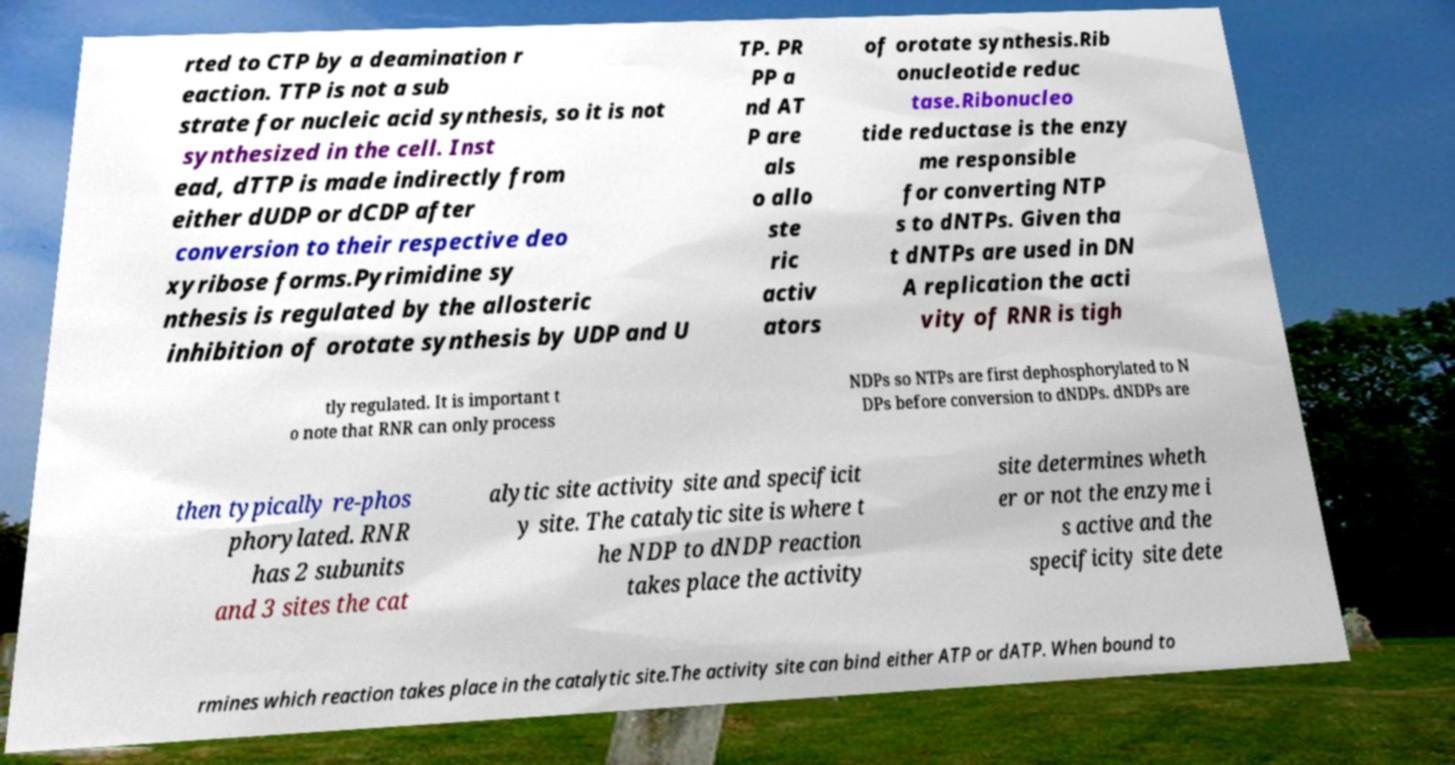Could you assist in decoding the text presented in this image and type it out clearly? rted to CTP by a deamination r eaction. TTP is not a sub strate for nucleic acid synthesis, so it is not synthesized in the cell. Inst ead, dTTP is made indirectly from either dUDP or dCDP after conversion to their respective deo xyribose forms.Pyrimidine sy nthesis is regulated by the allosteric inhibition of orotate synthesis by UDP and U TP. PR PP a nd AT P are als o allo ste ric activ ators of orotate synthesis.Rib onucleotide reduc tase.Ribonucleo tide reductase is the enzy me responsible for converting NTP s to dNTPs. Given tha t dNTPs are used in DN A replication the acti vity of RNR is tigh tly regulated. It is important t o note that RNR can only process NDPs so NTPs are first dephosphorylated to N DPs before conversion to dNDPs. dNDPs are then typically re-phos phorylated. RNR has 2 subunits and 3 sites the cat alytic site activity site and specificit y site. The catalytic site is where t he NDP to dNDP reaction takes place the activity site determines wheth er or not the enzyme i s active and the specificity site dete rmines which reaction takes place in the catalytic site.The activity site can bind either ATP or dATP. When bound to 